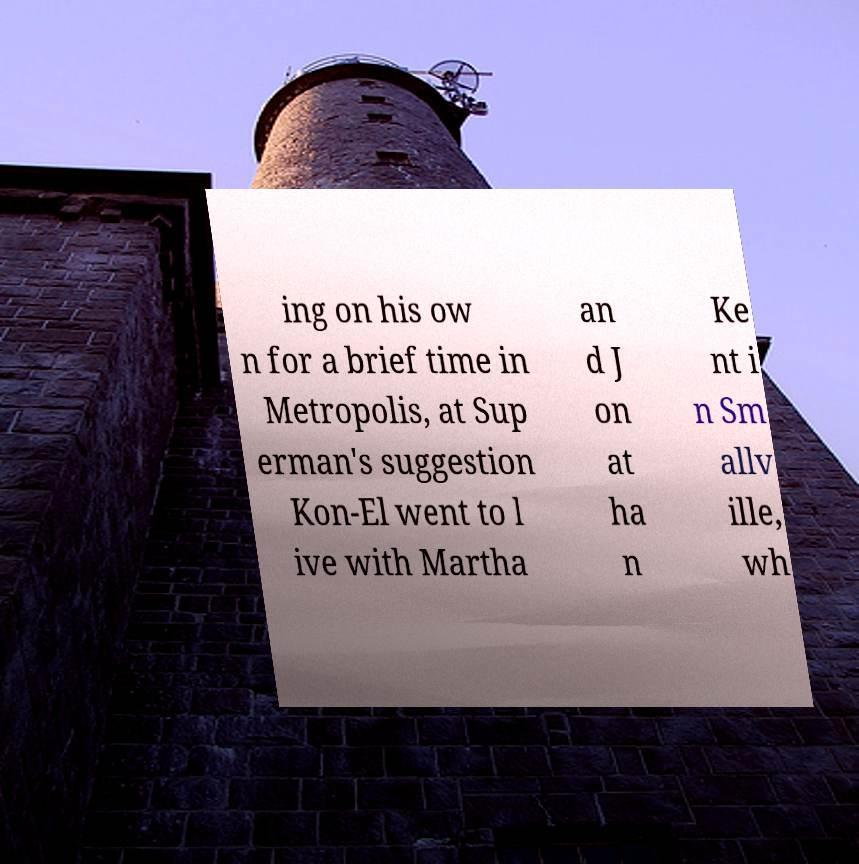Could you extract and type out the text from this image? ing on his ow n for a brief time in Metropolis, at Sup erman's suggestion Kon-El went to l ive with Martha an d J on at ha n Ke nt i n Sm allv ille, wh 